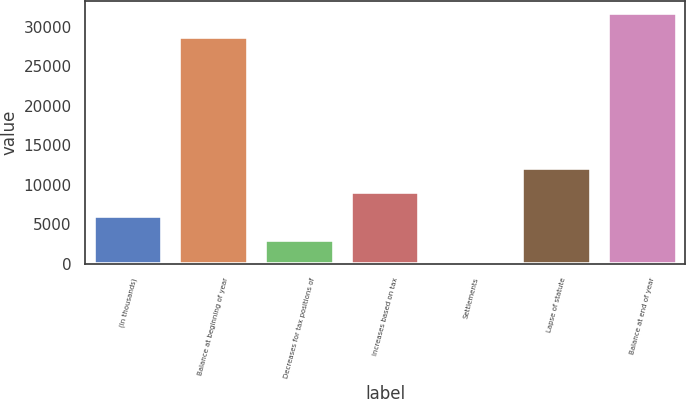<chart> <loc_0><loc_0><loc_500><loc_500><bar_chart><fcel>(In thousands)<fcel>Balance at beginning of year<fcel>Decreases for tax positions of<fcel>Increases based on tax<fcel>Settlements<fcel>Lapse of statute<fcel>Balance at end of year<nl><fcel>6089.2<fcel>28685<fcel>3066.6<fcel>9111.8<fcel>44<fcel>12134.4<fcel>31707.6<nl></chart> 